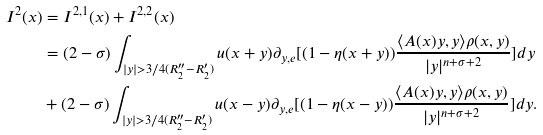Convert formula to latex. <formula><loc_0><loc_0><loc_500><loc_500>I ^ { 2 } ( x ) & = I ^ { 2 , 1 } ( x ) + I ^ { 2 , 2 } ( x ) \\ & = ( 2 - \sigma ) \int _ { | y | > 3 / 4 ( R _ { 2 } ^ { \prime \prime } - R _ { 2 } ^ { \prime } ) } u ( x + y ) \partial _ { y , e } [ ( 1 - \eta ( x + y ) ) \frac { \langle A ( x ) y , y \rangle \rho ( x , y ) } { | y | ^ { n + \sigma + 2 } } ] d y \\ & + ( 2 - \sigma ) \int _ { | y | > 3 / 4 ( R _ { 2 } ^ { \prime \prime } - R _ { 2 } ^ { \prime } ) } u ( x - y ) \partial _ { y , e } [ ( 1 - \eta ( x - y ) ) \frac { \langle A ( x ) y , y \rangle \rho ( x , y ) } { | y | ^ { n + \sigma + 2 } } ] d y .</formula> 